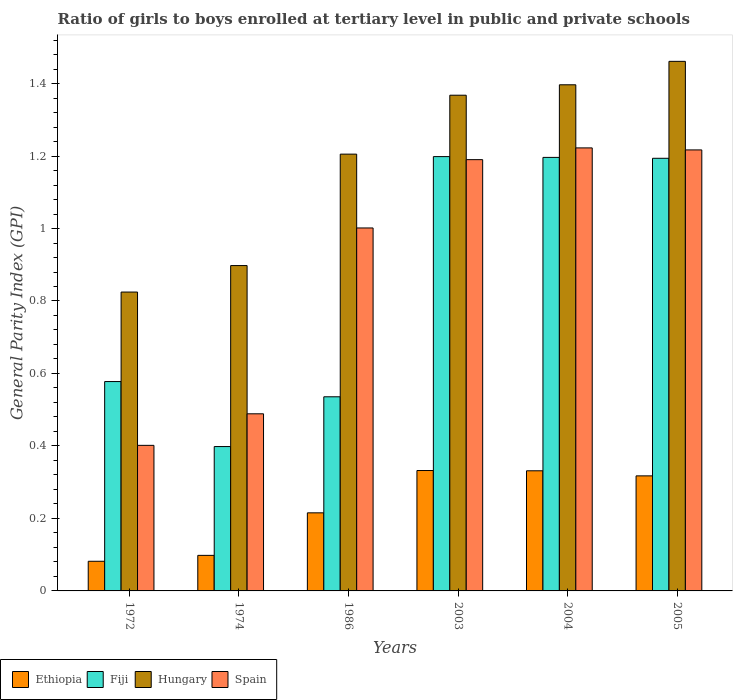How many groups of bars are there?
Offer a very short reply. 6. Are the number of bars per tick equal to the number of legend labels?
Make the answer very short. Yes. How many bars are there on the 1st tick from the right?
Keep it short and to the point. 4. What is the label of the 2nd group of bars from the left?
Keep it short and to the point. 1974. What is the general parity index in Spain in 2005?
Offer a very short reply. 1.22. Across all years, what is the maximum general parity index in Ethiopia?
Offer a terse response. 0.33. Across all years, what is the minimum general parity index in Spain?
Ensure brevity in your answer.  0.4. What is the total general parity index in Hungary in the graph?
Give a very brief answer. 7.15. What is the difference between the general parity index in Ethiopia in 1972 and that in 2003?
Provide a succinct answer. -0.25. What is the difference between the general parity index in Ethiopia in 1974 and the general parity index in Spain in 1972?
Keep it short and to the point. -0.3. What is the average general parity index in Fiji per year?
Your answer should be compact. 0.85. In the year 2003, what is the difference between the general parity index in Spain and general parity index in Fiji?
Your response must be concise. -0.01. In how many years, is the general parity index in Spain greater than 1.2800000000000002?
Provide a short and direct response. 0. What is the ratio of the general parity index in Ethiopia in 1974 to that in 2003?
Keep it short and to the point. 0.3. Is the difference between the general parity index in Spain in 1974 and 2004 greater than the difference between the general parity index in Fiji in 1974 and 2004?
Your response must be concise. Yes. What is the difference between the highest and the second highest general parity index in Spain?
Ensure brevity in your answer.  0.01. What is the difference between the highest and the lowest general parity index in Spain?
Your answer should be compact. 0.82. In how many years, is the general parity index in Spain greater than the average general parity index in Spain taken over all years?
Ensure brevity in your answer.  4. Is the sum of the general parity index in Fiji in 1974 and 1986 greater than the maximum general parity index in Spain across all years?
Provide a succinct answer. No. What does the 3rd bar from the left in 1986 represents?
Your answer should be very brief. Hungary. What does the 3rd bar from the right in 2003 represents?
Provide a succinct answer. Fiji. How many bars are there?
Offer a very short reply. 24. Are all the bars in the graph horizontal?
Make the answer very short. No. What is the difference between two consecutive major ticks on the Y-axis?
Your response must be concise. 0.2. How are the legend labels stacked?
Your answer should be very brief. Horizontal. What is the title of the graph?
Your answer should be compact. Ratio of girls to boys enrolled at tertiary level in public and private schools. What is the label or title of the X-axis?
Provide a succinct answer. Years. What is the label or title of the Y-axis?
Give a very brief answer. General Parity Index (GPI). What is the General Parity Index (GPI) of Ethiopia in 1972?
Offer a very short reply. 0.08. What is the General Parity Index (GPI) in Fiji in 1972?
Give a very brief answer. 0.58. What is the General Parity Index (GPI) in Hungary in 1972?
Give a very brief answer. 0.82. What is the General Parity Index (GPI) in Spain in 1972?
Offer a very short reply. 0.4. What is the General Parity Index (GPI) in Ethiopia in 1974?
Provide a succinct answer. 0.1. What is the General Parity Index (GPI) in Fiji in 1974?
Keep it short and to the point. 0.4. What is the General Parity Index (GPI) in Hungary in 1974?
Give a very brief answer. 0.9. What is the General Parity Index (GPI) of Spain in 1974?
Your answer should be very brief. 0.49. What is the General Parity Index (GPI) of Ethiopia in 1986?
Ensure brevity in your answer.  0.22. What is the General Parity Index (GPI) in Fiji in 1986?
Your answer should be compact. 0.54. What is the General Parity Index (GPI) of Hungary in 1986?
Provide a short and direct response. 1.21. What is the General Parity Index (GPI) in Spain in 1986?
Offer a terse response. 1. What is the General Parity Index (GPI) in Ethiopia in 2003?
Your answer should be very brief. 0.33. What is the General Parity Index (GPI) of Fiji in 2003?
Ensure brevity in your answer.  1.2. What is the General Parity Index (GPI) in Hungary in 2003?
Your answer should be very brief. 1.37. What is the General Parity Index (GPI) in Spain in 2003?
Ensure brevity in your answer.  1.19. What is the General Parity Index (GPI) in Ethiopia in 2004?
Make the answer very short. 0.33. What is the General Parity Index (GPI) of Fiji in 2004?
Provide a succinct answer. 1.2. What is the General Parity Index (GPI) in Hungary in 2004?
Make the answer very short. 1.4. What is the General Parity Index (GPI) in Spain in 2004?
Offer a terse response. 1.22. What is the General Parity Index (GPI) in Ethiopia in 2005?
Ensure brevity in your answer.  0.32. What is the General Parity Index (GPI) in Fiji in 2005?
Offer a very short reply. 1.19. What is the General Parity Index (GPI) of Hungary in 2005?
Keep it short and to the point. 1.46. What is the General Parity Index (GPI) in Spain in 2005?
Offer a terse response. 1.22. Across all years, what is the maximum General Parity Index (GPI) in Ethiopia?
Your answer should be compact. 0.33. Across all years, what is the maximum General Parity Index (GPI) of Fiji?
Provide a short and direct response. 1.2. Across all years, what is the maximum General Parity Index (GPI) of Hungary?
Make the answer very short. 1.46. Across all years, what is the maximum General Parity Index (GPI) in Spain?
Offer a very short reply. 1.22. Across all years, what is the minimum General Parity Index (GPI) in Ethiopia?
Give a very brief answer. 0.08. Across all years, what is the minimum General Parity Index (GPI) in Fiji?
Your response must be concise. 0.4. Across all years, what is the minimum General Parity Index (GPI) in Hungary?
Offer a very short reply. 0.82. Across all years, what is the minimum General Parity Index (GPI) of Spain?
Your response must be concise. 0.4. What is the total General Parity Index (GPI) in Ethiopia in the graph?
Provide a short and direct response. 1.38. What is the total General Parity Index (GPI) of Fiji in the graph?
Your answer should be very brief. 5.1. What is the total General Parity Index (GPI) in Hungary in the graph?
Provide a short and direct response. 7.15. What is the total General Parity Index (GPI) in Spain in the graph?
Your answer should be very brief. 5.52. What is the difference between the General Parity Index (GPI) of Ethiopia in 1972 and that in 1974?
Provide a short and direct response. -0.02. What is the difference between the General Parity Index (GPI) of Fiji in 1972 and that in 1974?
Provide a succinct answer. 0.18. What is the difference between the General Parity Index (GPI) of Hungary in 1972 and that in 1974?
Your answer should be compact. -0.07. What is the difference between the General Parity Index (GPI) in Spain in 1972 and that in 1974?
Provide a short and direct response. -0.09. What is the difference between the General Parity Index (GPI) in Ethiopia in 1972 and that in 1986?
Offer a terse response. -0.13. What is the difference between the General Parity Index (GPI) in Fiji in 1972 and that in 1986?
Offer a very short reply. 0.04. What is the difference between the General Parity Index (GPI) in Hungary in 1972 and that in 1986?
Offer a very short reply. -0.38. What is the difference between the General Parity Index (GPI) of Spain in 1972 and that in 1986?
Offer a terse response. -0.6. What is the difference between the General Parity Index (GPI) in Ethiopia in 1972 and that in 2003?
Make the answer very short. -0.25. What is the difference between the General Parity Index (GPI) in Fiji in 1972 and that in 2003?
Give a very brief answer. -0.62. What is the difference between the General Parity Index (GPI) of Hungary in 1972 and that in 2003?
Provide a succinct answer. -0.54. What is the difference between the General Parity Index (GPI) of Spain in 1972 and that in 2003?
Provide a succinct answer. -0.79. What is the difference between the General Parity Index (GPI) of Ethiopia in 1972 and that in 2004?
Offer a terse response. -0.25. What is the difference between the General Parity Index (GPI) in Fiji in 1972 and that in 2004?
Ensure brevity in your answer.  -0.62. What is the difference between the General Parity Index (GPI) of Hungary in 1972 and that in 2004?
Keep it short and to the point. -0.57. What is the difference between the General Parity Index (GPI) of Spain in 1972 and that in 2004?
Your answer should be compact. -0.82. What is the difference between the General Parity Index (GPI) of Ethiopia in 1972 and that in 2005?
Your answer should be very brief. -0.24. What is the difference between the General Parity Index (GPI) of Fiji in 1972 and that in 2005?
Your response must be concise. -0.62. What is the difference between the General Parity Index (GPI) in Hungary in 1972 and that in 2005?
Your answer should be very brief. -0.64. What is the difference between the General Parity Index (GPI) in Spain in 1972 and that in 2005?
Provide a succinct answer. -0.82. What is the difference between the General Parity Index (GPI) in Ethiopia in 1974 and that in 1986?
Give a very brief answer. -0.12. What is the difference between the General Parity Index (GPI) of Fiji in 1974 and that in 1986?
Your answer should be compact. -0.14. What is the difference between the General Parity Index (GPI) in Hungary in 1974 and that in 1986?
Your answer should be compact. -0.31. What is the difference between the General Parity Index (GPI) in Spain in 1974 and that in 1986?
Your answer should be compact. -0.51. What is the difference between the General Parity Index (GPI) of Ethiopia in 1974 and that in 2003?
Your response must be concise. -0.23. What is the difference between the General Parity Index (GPI) in Fiji in 1974 and that in 2003?
Keep it short and to the point. -0.8. What is the difference between the General Parity Index (GPI) in Hungary in 1974 and that in 2003?
Your answer should be very brief. -0.47. What is the difference between the General Parity Index (GPI) of Spain in 1974 and that in 2003?
Your response must be concise. -0.7. What is the difference between the General Parity Index (GPI) in Ethiopia in 1974 and that in 2004?
Offer a very short reply. -0.23. What is the difference between the General Parity Index (GPI) in Fiji in 1974 and that in 2004?
Offer a very short reply. -0.8. What is the difference between the General Parity Index (GPI) in Hungary in 1974 and that in 2004?
Your answer should be compact. -0.5. What is the difference between the General Parity Index (GPI) in Spain in 1974 and that in 2004?
Keep it short and to the point. -0.73. What is the difference between the General Parity Index (GPI) of Ethiopia in 1974 and that in 2005?
Keep it short and to the point. -0.22. What is the difference between the General Parity Index (GPI) in Fiji in 1974 and that in 2005?
Offer a very short reply. -0.8. What is the difference between the General Parity Index (GPI) in Hungary in 1974 and that in 2005?
Keep it short and to the point. -0.56. What is the difference between the General Parity Index (GPI) of Spain in 1974 and that in 2005?
Make the answer very short. -0.73. What is the difference between the General Parity Index (GPI) in Ethiopia in 1986 and that in 2003?
Your answer should be very brief. -0.12. What is the difference between the General Parity Index (GPI) of Fiji in 1986 and that in 2003?
Keep it short and to the point. -0.66. What is the difference between the General Parity Index (GPI) in Hungary in 1986 and that in 2003?
Offer a very short reply. -0.16. What is the difference between the General Parity Index (GPI) of Spain in 1986 and that in 2003?
Ensure brevity in your answer.  -0.19. What is the difference between the General Parity Index (GPI) of Ethiopia in 1986 and that in 2004?
Your answer should be very brief. -0.12. What is the difference between the General Parity Index (GPI) of Fiji in 1986 and that in 2004?
Make the answer very short. -0.66. What is the difference between the General Parity Index (GPI) of Hungary in 1986 and that in 2004?
Your answer should be compact. -0.19. What is the difference between the General Parity Index (GPI) of Spain in 1986 and that in 2004?
Provide a succinct answer. -0.22. What is the difference between the General Parity Index (GPI) of Ethiopia in 1986 and that in 2005?
Ensure brevity in your answer.  -0.1. What is the difference between the General Parity Index (GPI) of Fiji in 1986 and that in 2005?
Your answer should be compact. -0.66. What is the difference between the General Parity Index (GPI) in Hungary in 1986 and that in 2005?
Provide a short and direct response. -0.26. What is the difference between the General Parity Index (GPI) in Spain in 1986 and that in 2005?
Provide a short and direct response. -0.22. What is the difference between the General Parity Index (GPI) in Ethiopia in 2003 and that in 2004?
Offer a very short reply. 0. What is the difference between the General Parity Index (GPI) in Fiji in 2003 and that in 2004?
Give a very brief answer. 0. What is the difference between the General Parity Index (GPI) in Hungary in 2003 and that in 2004?
Make the answer very short. -0.03. What is the difference between the General Parity Index (GPI) of Spain in 2003 and that in 2004?
Provide a succinct answer. -0.03. What is the difference between the General Parity Index (GPI) in Ethiopia in 2003 and that in 2005?
Provide a succinct answer. 0.01. What is the difference between the General Parity Index (GPI) in Fiji in 2003 and that in 2005?
Give a very brief answer. 0. What is the difference between the General Parity Index (GPI) in Hungary in 2003 and that in 2005?
Ensure brevity in your answer.  -0.09. What is the difference between the General Parity Index (GPI) in Spain in 2003 and that in 2005?
Provide a succinct answer. -0.03. What is the difference between the General Parity Index (GPI) of Ethiopia in 2004 and that in 2005?
Ensure brevity in your answer.  0.01. What is the difference between the General Parity Index (GPI) of Fiji in 2004 and that in 2005?
Your answer should be compact. 0. What is the difference between the General Parity Index (GPI) of Hungary in 2004 and that in 2005?
Provide a succinct answer. -0.06. What is the difference between the General Parity Index (GPI) of Spain in 2004 and that in 2005?
Provide a short and direct response. 0.01. What is the difference between the General Parity Index (GPI) in Ethiopia in 1972 and the General Parity Index (GPI) in Fiji in 1974?
Offer a very short reply. -0.32. What is the difference between the General Parity Index (GPI) of Ethiopia in 1972 and the General Parity Index (GPI) of Hungary in 1974?
Your response must be concise. -0.82. What is the difference between the General Parity Index (GPI) in Ethiopia in 1972 and the General Parity Index (GPI) in Spain in 1974?
Keep it short and to the point. -0.41. What is the difference between the General Parity Index (GPI) of Fiji in 1972 and the General Parity Index (GPI) of Hungary in 1974?
Your response must be concise. -0.32. What is the difference between the General Parity Index (GPI) in Fiji in 1972 and the General Parity Index (GPI) in Spain in 1974?
Give a very brief answer. 0.09. What is the difference between the General Parity Index (GPI) in Hungary in 1972 and the General Parity Index (GPI) in Spain in 1974?
Offer a very short reply. 0.34. What is the difference between the General Parity Index (GPI) of Ethiopia in 1972 and the General Parity Index (GPI) of Fiji in 1986?
Offer a terse response. -0.45. What is the difference between the General Parity Index (GPI) in Ethiopia in 1972 and the General Parity Index (GPI) in Hungary in 1986?
Offer a very short reply. -1.12. What is the difference between the General Parity Index (GPI) in Ethiopia in 1972 and the General Parity Index (GPI) in Spain in 1986?
Offer a terse response. -0.92. What is the difference between the General Parity Index (GPI) of Fiji in 1972 and the General Parity Index (GPI) of Hungary in 1986?
Your answer should be very brief. -0.63. What is the difference between the General Parity Index (GPI) of Fiji in 1972 and the General Parity Index (GPI) of Spain in 1986?
Give a very brief answer. -0.42. What is the difference between the General Parity Index (GPI) of Hungary in 1972 and the General Parity Index (GPI) of Spain in 1986?
Provide a short and direct response. -0.18. What is the difference between the General Parity Index (GPI) in Ethiopia in 1972 and the General Parity Index (GPI) in Fiji in 2003?
Provide a short and direct response. -1.12. What is the difference between the General Parity Index (GPI) in Ethiopia in 1972 and the General Parity Index (GPI) in Hungary in 2003?
Provide a succinct answer. -1.29. What is the difference between the General Parity Index (GPI) in Ethiopia in 1972 and the General Parity Index (GPI) in Spain in 2003?
Your response must be concise. -1.11. What is the difference between the General Parity Index (GPI) of Fiji in 1972 and the General Parity Index (GPI) of Hungary in 2003?
Provide a succinct answer. -0.79. What is the difference between the General Parity Index (GPI) in Fiji in 1972 and the General Parity Index (GPI) in Spain in 2003?
Your response must be concise. -0.61. What is the difference between the General Parity Index (GPI) of Hungary in 1972 and the General Parity Index (GPI) of Spain in 2003?
Provide a succinct answer. -0.37. What is the difference between the General Parity Index (GPI) of Ethiopia in 1972 and the General Parity Index (GPI) of Fiji in 2004?
Provide a short and direct response. -1.11. What is the difference between the General Parity Index (GPI) in Ethiopia in 1972 and the General Parity Index (GPI) in Hungary in 2004?
Give a very brief answer. -1.31. What is the difference between the General Parity Index (GPI) of Ethiopia in 1972 and the General Parity Index (GPI) of Spain in 2004?
Your response must be concise. -1.14. What is the difference between the General Parity Index (GPI) of Fiji in 1972 and the General Parity Index (GPI) of Hungary in 2004?
Offer a very short reply. -0.82. What is the difference between the General Parity Index (GPI) of Fiji in 1972 and the General Parity Index (GPI) of Spain in 2004?
Offer a very short reply. -0.64. What is the difference between the General Parity Index (GPI) in Hungary in 1972 and the General Parity Index (GPI) in Spain in 2004?
Provide a short and direct response. -0.4. What is the difference between the General Parity Index (GPI) of Ethiopia in 1972 and the General Parity Index (GPI) of Fiji in 2005?
Ensure brevity in your answer.  -1.11. What is the difference between the General Parity Index (GPI) in Ethiopia in 1972 and the General Parity Index (GPI) in Hungary in 2005?
Make the answer very short. -1.38. What is the difference between the General Parity Index (GPI) in Ethiopia in 1972 and the General Parity Index (GPI) in Spain in 2005?
Your answer should be compact. -1.14. What is the difference between the General Parity Index (GPI) in Fiji in 1972 and the General Parity Index (GPI) in Hungary in 2005?
Ensure brevity in your answer.  -0.88. What is the difference between the General Parity Index (GPI) of Fiji in 1972 and the General Parity Index (GPI) of Spain in 2005?
Provide a short and direct response. -0.64. What is the difference between the General Parity Index (GPI) of Hungary in 1972 and the General Parity Index (GPI) of Spain in 2005?
Keep it short and to the point. -0.39. What is the difference between the General Parity Index (GPI) of Ethiopia in 1974 and the General Parity Index (GPI) of Fiji in 1986?
Provide a short and direct response. -0.44. What is the difference between the General Parity Index (GPI) of Ethiopia in 1974 and the General Parity Index (GPI) of Hungary in 1986?
Your answer should be very brief. -1.11. What is the difference between the General Parity Index (GPI) of Ethiopia in 1974 and the General Parity Index (GPI) of Spain in 1986?
Ensure brevity in your answer.  -0.9. What is the difference between the General Parity Index (GPI) of Fiji in 1974 and the General Parity Index (GPI) of Hungary in 1986?
Provide a succinct answer. -0.81. What is the difference between the General Parity Index (GPI) in Fiji in 1974 and the General Parity Index (GPI) in Spain in 1986?
Give a very brief answer. -0.6. What is the difference between the General Parity Index (GPI) of Hungary in 1974 and the General Parity Index (GPI) of Spain in 1986?
Give a very brief answer. -0.1. What is the difference between the General Parity Index (GPI) of Ethiopia in 1974 and the General Parity Index (GPI) of Fiji in 2003?
Your answer should be compact. -1.1. What is the difference between the General Parity Index (GPI) in Ethiopia in 1974 and the General Parity Index (GPI) in Hungary in 2003?
Offer a terse response. -1.27. What is the difference between the General Parity Index (GPI) of Ethiopia in 1974 and the General Parity Index (GPI) of Spain in 2003?
Give a very brief answer. -1.09. What is the difference between the General Parity Index (GPI) in Fiji in 1974 and the General Parity Index (GPI) in Hungary in 2003?
Make the answer very short. -0.97. What is the difference between the General Parity Index (GPI) of Fiji in 1974 and the General Parity Index (GPI) of Spain in 2003?
Offer a terse response. -0.79. What is the difference between the General Parity Index (GPI) in Hungary in 1974 and the General Parity Index (GPI) in Spain in 2003?
Your answer should be very brief. -0.29. What is the difference between the General Parity Index (GPI) in Ethiopia in 1974 and the General Parity Index (GPI) in Fiji in 2004?
Make the answer very short. -1.1. What is the difference between the General Parity Index (GPI) of Ethiopia in 1974 and the General Parity Index (GPI) of Hungary in 2004?
Provide a short and direct response. -1.3. What is the difference between the General Parity Index (GPI) of Ethiopia in 1974 and the General Parity Index (GPI) of Spain in 2004?
Your answer should be very brief. -1.12. What is the difference between the General Parity Index (GPI) in Fiji in 1974 and the General Parity Index (GPI) in Hungary in 2004?
Your answer should be compact. -1. What is the difference between the General Parity Index (GPI) in Fiji in 1974 and the General Parity Index (GPI) in Spain in 2004?
Your response must be concise. -0.82. What is the difference between the General Parity Index (GPI) in Hungary in 1974 and the General Parity Index (GPI) in Spain in 2004?
Your answer should be compact. -0.32. What is the difference between the General Parity Index (GPI) of Ethiopia in 1974 and the General Parity Index (GPI) of Fiji in 2005?
Offer a terse response. -1.1. What is the difference between the General Parity Index (GPI) in Ethiopia in 1974 and the General Parity Index (GPI) in Hungary in 2005?
Your answer should be compact. -1.36. What is the difference between the General Parity Index (GPI) of Ethiopia in 1974 and the General Parity Index (GPI) of Spain in 2005?
Offer a terse response. -1.12. What is the difference between the General Parity Index (GPI) of Fiji in 1974 and the General Parity Index (GPI) of Hungary in 2005?
Provide a short and direct response. -1.06. What is the difference between the General Parity Index (GPI) in Fiji in 1974 and the General Parity Index (GPI) in Spain in 2005?
Give a very brief answer. -0.82. What is the difference between the General Parity Index (GPI) in Hungary in 1974 and the General Parity Index (GPI) in Spain in 2005?
Keep it short and to the point. -0.32. What is the difference between the General Parity Index (GPI) of Ethiopia in 1986 and the General Parity Index (GPI) of Fiji in 2003?
Your response must be concise. -0.98. What is the difference between the General Parity Index (GPI) in Ethiopia in 1986 and the General Parity Index (GPI) in Hungary in 2003?
Make the answer very short. -1.15. What is the difference between the General Parity Index (GPI) in Ethiopia in 1986 and the General Parity Index (GPI) in Spain in 2003?
Provide a short and direct response. -0.97. What is the difference between the General Parity Index (GPI) in Fiji in 1986 and the General Parity Index (GPI) in Hungary in 2003?
Keep it short and to the point. -0.83. What is the difference between the General Parity Index (GPI) of Fiji in 1986 and the General Parity Index (GPI) of Spain in 2003?
Make the answer very short. -0.65. What is the difference between the General Parity Index (GPI) in Hungary in 1986 and the General Parity Index (GPI) in Spain in 2003?
Your response must be concise. 0.02. What is the difference between the General Parity Index (GPI) of Ethiopia in 1986 and the General Parity Index (GPI) of Fiji in 2004?
Offer a very short reply. -0.98. What is the difference between the General Parity Index (GPI) of Ethiopia in 1986 and the General Parity Index (GPI) of Hungary in 2004?
Provide a succinct answer. -1.18. What is the difference between the General Parity Index (GPI) of Ethiopia in 1986 and the General Parity Index (GPI) of Spain in 2004?
Ensure brevity in your answer.  -1.01. What is the difference between the General Parity Index (GPI) in Fiji in 1986 and the General Parity Index (GPI) in Hungary in 2004?
Provide a short and direct response. -0.86. What is the difference between the General Parity Index (GPI) of Fiji in 1986 and the General Parity Index (GPI) of Spain in 2004?
Ensure brevity in your answer.  -0.69. What is the difference between the General Parity Index (GPI) of Hungary in 1986 and the General Parity Index (GPI) of Spain in 2004?
Your answer should be very brief. -0.02. What is the difference between the General Parity Index (GPI) in Ethiopia in 1986 and the General Parity Index (GPI) in Fiji in 2005?
Offer a very short reply. -0.98. What is the difference between the General Parity Index (GPI) of Ethiopia in 1986 and the General Parity Index (GPI) of Hungary in 2005?
Offer a terse response. -1.25. What is the difference between the General Parity Index (GPI) in Ethiopia in 1986 and the General Parity Index (GPI) in Spain in 2005?
Your answer should be compact. -1. What is the difference between the General Parity Index (GPI) in Fiji in 1986 and the General Parity Index (GPI) in Hungary in 2005?
Ensure brevity in your answer.  -0.93. What is the difference between the General Parity Index (GPI) in Fiji in 1986 and the General Parity Index (GPI) in Spain in 2005?
Your response must be concise. -0.68. What is the difference between the General Parity Index (GPI) in Hungary in 1986 and the General Parity Index (GPI) in Spain in 2005?
Offer a terse response. -0.01. What is the difference between the General Parity Index (GPI) of Ethiopia in 2003 and the General Parity Index (GPI) of Fiji in 2004?
Keep it short and to the point. -0.86. What is the difference between the General Parity Index (GPI) in Ethiopia in 2003 and the General Parity Index (GPI) in Hungary in 2004?
Make the answer very short. -1.06. What is the difference between the General Parity Index (GPI) in Ethiopia in 2003 and the General Parity Index (GPI) in Spain in 2004?
Your answer should be compact. -0.89. What is the difference between the General Parity Index (GPI) of Fiji in 2003 and the General Parity Index (GPI) of Hungary in 2004?
Offer a terse response. -0.2. What is the difference between the General Parity Index (GPI) of Fiji in 2003 and the General Parity Index (GPI) of Spain in 2004?
Make the answer very short. -0.02. What is the difference between the General Parity Index (GPI) of Hungary in 2003 and the General Parity Index (GPI) of Spain in 2004?
Make the answer very short. 0.15. What is the difference between the General Parity Index (GPI) in Ethiopia in 2003 and the General Parity Index (GPI) in Fiji in 2005?
Ensure brevity in your answer.  -0.86. What is the difference between the General Parity Index (GPI) of Ethiopia in 2003 and the General Parity Index (GPI) of Hungary in 2005?
Keep it short and to the point. -1.13. What is the difference between the General Parity Index (GPI) of Ethiopia in 2003 and the General Parity Index (GPI) of Spain in 2005?
Give a very brief answer. -0.88. What is the difference between the General Parity Index (GPI) in Fiji in 2003 and the General Parity Index (GPI) in Hungary in 2005?
Make the answer very short. -0.26. What is the difference between the General Parity Index (GPI) in Fiji in 2003 and the General Parity Index (GPI) in Spain in 2005?
Your answer should be very brief. -0.02. What is the difference between the General Parity Index (GPI) of Hungary in 2003 and the General Parity Index (GPI) of Spain in 2005?
Keep it short and to the point. 0.15. What is the difference between the General Parity Index (GPI) of Ethiopia in 2004 and the General Parity Index (GPI) of Fiji in 2005?
Your answer should be compact. -0.86. What is the difference between the General Parity Index (GPI) in Ethiopia in 2004 and the General Parity Index (GPI) in Hungary in 2005?
Offer a terse response. -1.13. What is the difference between the General Parity Index (GPI) in Ethiopia in 2004 and the General Parity Index (GPI) in Spain in 2005?
Your answer should be compact. -0.89. What is the difference between the General Parity Index (GPI) of Fiji in 2004 and the General Parity Index (GPI) of Hungary in 2005?
Your answer should be compact. -0.27. What is the difference between the General Parity Index (GPI) in Fiji in 2004 and the General Parity Index (GPI) in Spain in 2005?
Keep it short and to the point. -0.02. What is the difference between the General Parity Index (GPI) in Hungary in 2004 and the General Parity Index (GPI) in Spain in 2005?
Keep it short and to the point. 0.18. What is the average General Parity Index (GPI) of Ethiopia per year?
Provide a short and direct response. 0.23. What is the average General Parity Index (GPI) in Hungary per year?
Keep it short and to the point. 1.19. What is the average General Parity Index (GPI) of Spain per year?
Provide a succinct answer. 0.92. In the year 1972, what is the difference between the General Parity Index (GPI) of Ethiopia and General Parity Index (GPI) of Fiji?
Your response must be concise. -0.5. In the year 1972, what is the difference between the General Parity Index (GPI) of Ethiopia and General Parity Index (GPI) of Hungary?
Offer a terse response. -0.74. In the year 1972, what is the difference between the General Parity Index (GPI) in Ethiopia and General Parity Index (GPI) in Spain?
Provide a short and direct response. -0.32. In the year 1972, what is the difference between the General Parity Index (GPI) of Fiji and General Parity Index (GPI) of Hungary?
Provide a succinct answer. -0.25. In the year 1972, what is the difference between the General Parity Index (GPI) of Fiji and General Parity Index (GPI) of Spain?
Offer a very short reply. 0.18. In the year 1972, what is the difference between the General Parity Index (GPI) of Hungary and General Parity Index (GPI) of Spain?
Your answer should be compact. 0.42. In the year 1974, what is the difference between the General Parity Index (GPI) of Ethiopia and General Parity Index (GPI) of Fiji?
Ensure brevity in your answer.  -0.3. In the year 1974, what is the difference between the General Parity Index (GPI) of Ethiopia and General Parity Index (GPI) of Hungary?
Ensure brevity in your answer.  -0.8. In the year 1974, what is the difference between the General Parity Index (GPI) of Ethiopia and General Parity Index (GPI) of Spain?
Provide a succinct answer. -0.39. In the year 1974, what is the difference between the General Parity Index (GPI) of Fiji and General Parity Index (GPI) of Hungary?
Your answer should be very brief. -0.5. In the year 1974, what is the difference between the General Parity Index (GPI) of Fiji and General Parity Index (GPI) of Spain?
Provide a short and direct response. -0.09. In the year 1974, what is the difference between the General Parity Index (GPI) in Hungary and General Parity Index (GPI) in Spain?
Your response must be concise. 0.41. In the year 1986, what is the difference between the General Parity Index (GPI) in Ethiopia and General Parity Index (GPI) in Fiji?
Your answer should be compact. -0.32. In the year 1986, what is the difference between the General Parity Index (GPI) of Ethiopia and General Parity Index (GPI) of Hungary?
Offer a terse response. -0.99. In the year 1986, what is the difference between the General Parity Index (GPI) of Ethiopia and General Parity Index (GPI) of Spain?
Provide a succinct answer. -0.79. In the year 1986, what is the difference between the General Parity Index (GPI) in Fiji and General Parity Index (GPI) in Hungary?
Your response must be concise. -0.67. In the year 1986, what is the difference between the General Parity Index (GPI) in Fiji and General Parity Index (GPI) in Spain?
Make the answer very short. -0.47. In the year 1986, what is the difference between the General Parity Index (GPI) of Hungary and General Parity Index (GPI) of Spain?
Your answer should be compact. 0.2. In the year 2003, what is the difference between the General Parity Index (GPI) in Ethiopia and General Parity Index (GPI) in Fiji?
Offer a terse response. -0.87. In the year 2003, what is the difference between the General Parity Index (GPI) of Ethiopia and General Parity Index (GPI) of Hungary?
Offer a terse response. -1.04. In the year 2003, what is the difference between the General Parity Index (GPI) in Ethiopia and General Parity Index (GPI) in Spain?
Provide a succinct answer. -0.86. In the year 2003, what is the difference between the General Parity Index (GPI) of Fiji and General Parity Index (GPI) of Hungary?
Offer a terse response. -0.17. In the year 2003, what is the difference between the General Parity Index (GPI) in Fiji and General Parity Index (GPI) in Spain?
Provide a short and direct response. 0.01. In the year 2003, what is the difference between the General Parity Index (GPI) in Hungary and General Parity Index (GPI) in Spain?
Ensure brevity in your answer.  0.18. In the year 2004, what is the difference between the General Parity Index (GPI) in Ethiopia and General Parity Index (GPI) in Fiji?
Your response must be concise. -0.86. In the year 2004, what is the difference between the General Parity Index (GPI) of Ethiopia and General Parity Index (GPI) of Hungary?
Your answer should be compact. -1.07. In the year 2004, what is the difference between the General Parity Index (GPI) in Ethiopia and General Parity Index (GPI) in Spain?
Offer a very short reply. -0.89. In the year 2004, what is the difference between the General Parity Index (GPI) in Fiji and General Parity Index (GPI) in Hungary?
Offer a terse response. -0.2. In the year 2004, what is the difference between the General Parity Index (GPI) of Fiji and General Parity Index (GPI) of Spain?
Make the answer very short. -0.03. In the year 2004, what is the difference between the General Parity Index (GPI) of Hungary and General Parity Index (GPI) of Spain?
Provide a succinct answer. 0.17. In the year 2005, what is the difference between the General Parity Index (GPI) in Ethiopia and General Parity Index (GPI) in Fiji?
Your response must be concise. -0.88. In the year 2005, what is the difference between the General Parity Index (GPI) in Ethiopia and General Parity Index (GPI) in Hungary?
Provide a succinct answer. -1.14. In the year 2005, what is the difference between the General Parity Index (GPI) in Ethiopia and General Parity Index (GPI) in Spain?
Offer a very short reply. -0.9. In the year 2005, what is the difference between the General Parity Index (GPI) of Fiji and General Parity Index (GPI) of Hungary?
Your response must be concise. -0.27. In the year 2005, what is the difference between the General Parity Index (GPI) of Fiji and General Parity Index (GPI) of Spain?
Ensure brevity in your answer.  -0.02. In the year 2005, what is the difference between the General Parity Index (GPI) in Hungary and General Parity Index (GPI) in Spain?
Make the answer very short. 0.24. What is the ratio of the General Parity Index (GPI) in Ethiopia in 1972 to that in 1974?
Your answer should be compact. 0.83. What is the ratio of the General Parity Index (GPI) of Fiji in 1972 to that in 1974?
Give a very brief answer. 1.45. What is the ratio of the General Parity Index (GPI) of Hungary in 1972 to that in 1974?
Make the answer very short. 0.92. What is the ratio of the General Parity Index (GPI) of Spain in 1972 to that in 1974?
Offer a terse response. 0.82. What is the ratio of the General Parity Index (GPI) in Ethiopia in 1972 to that in 1986?
Your answer should be compact. 0.38. What is the ratio of the General Parity Index (GPI) of Fiji in 1972 to that in 1986?
Your answer should be very brief. 1.08. What is the ratio of the General Parity Index (GPI) of Hungary in 1972 to that in 1986?
Your response must be concise. 0.68. What is the ratio of the General Parity Index (GPI) in Spain in 1972 to that in 1986?
Provide a short and direct response. 0.4. What is the ratio of the General Parity Index (GPI) in Ethiopia in 1972 to that in 2003?
Your answer should be compact. 0.25. What is the ratio of the General Parity Index (GPI) of Fiji in 1972 to that in 2003?
Keep it short and to the point. 0.48. What is the ratio of the General Parity Index (GPI) of Hungary in 1972 to that in 2003?
Offer a terse response. 0.6. What is the ratio of the General Parity Index (GPI) in Spain in 1972 to that in 2003?
Your answer should be compact. 0.34. What is the ratio of the General Parity Index (GPI) in Ethiopia in 1972 to that in 2004?
Ensure brevity in your answer.  0.25. What is the ratio of the General Parity Index (GPI) in Fiji in 1972 to that in 2004?
Provide a succinct answer. 0.48. What is the ratio of the General Parity Index (GPI) in Hungary in 1972 to that in 2004?
Offer a very short reply. 0.59. What is the ratio of the General Parity Index (GPI) of Spain in 1972 to that in 2004?
Ensure brevity in your answer.  0.33. What is the ratio of the General Parity Index (GPI) in Ethiopia in 1972 to that in 2005?
Provide a succinct answer. 0.26. What is the ratio of the General Parity Index (GPI) of Fiji in 1972 to that in 2005?
Ensure brevity in your answer.  0.48. What is the ratio of the General Parity Index (GPI) of Hungary in 1972 to that in 2005?
Ensure brevity in your answer.  0.56. What is the ratio of the General Parity Index (GPI) in Spain in 1972 to that in 2005?
Offer a terse response. 0.33. What is the ratio of the General Parity Index (GPI) of Ethiopia in 1974 to that in 1986?
Offer a very short reply. 0.46. What is the ratio of the General Parity Index (GPI) of Fiji in 1974 to that in 1986?
Provide a short and direct response. 0.74. What is the ratio of the General Parity Index (GPI) in Hungary in 1974 to that in 1986?
Your answer should be very brief. 0.74. What is the ratio of the General Parity Index (GPI) in Spain in 1974 to that in 1986?
Make the answer very short. 0.49. What is the ratio of the General Parity Index (GPI) of Ethiopia in 1974 to that in 2003?
Your answer should be compact. 0.3. What is the ratio of the General Parity Index (GPI) in Fiji in 1974 to that in 2003?
Keep it short and to the point. 0.33. What is the ratio of the General Parity Index (GPI) in Hungary in 1974 to that in 2003?
Provide a short and direct response. 0.66. What is the ratio of the General Parity Index (GPI) of Spain in 1974 to that in 2003?
Make the answer very short. 0.41. What is the ratio of the General Parity Index (GPI) of Ethiopia in 1974 to that in 2004?
Your response must be concise. 0.3. What is the ratio of the General Parity Index (GPI) in Fiji in 1974 to that in 2004?
Give a very brief answer. 0.33. What is the ratio of the General Parity Index (GPI) in Hungary in 1974 to that in 2004?
Keep it short and to the point. 0.64. What is the ratio of the General Parity Index (GPI) in Spain in 1974 to that in 2004?
Offer a very short reply. 0.4. What is the ratio of the General Parity Index (GPI) of Ethiopia in 1974 to that in 2005?
Offer a terse response. 0.31. What is the ratio of the General Parity Index (GPI) in Fiji in 1974 to that in 2005?
Make the answer very short. 0.33. What is the ratio of the General Parity Index (GPI) in Hungary in 1974 to that in 2005?
Your answer should be very brief. 0.61. What is the ratio of the General Parity Index (GPI) of Spain in 1974 to that in 2005?
Offer a very short reply. 0.4. What is the ratio of the General Parity Index (GPI) of Ethiopia in 1986 to that in 2003?
Make the answer very short. 0.65. What is the ratio of the General Parity Index (GPI) in Fiji in 1986 to that in 2003?
Your answer should be very brief. 0.45. What is the ratio of the General Parity Index (GPI) in Hungary in 1986 to that in 2003?
Make the answer very short. 0.88. What is the ratio of the General Parity Index (GPI) of Spain in 1986 to that in 2003?
Your response must be concise. 0.84. What is the ratio of the General Parity Index (GPI) in Ethiopia in 1986 to that in 2004?
Give a very brief answer. 0.65. What is the ratio of the General Parity Index (GPI) of Fiji in 1986 to that in 2004?
Offer a terse response. 0.45. What is the ratio of the General Parity Index (GPI) of Hungary in 1986 to that in 2004?
Your answer should be compact. 0.86. What is the ratio of the General Parity Index (GPI) of Spain in 1986 to that in 2004?
Provide a short and direct response. 0.82. What is the ratio of the General Parity Index (GPI) of Ethiopia in 1986 to that in 2005?
Make the answer very short. 0.68. What is the ratio of the General Parity Index (GPI) of Fiji in 1986 to that in 2005?
Make the answer very short. 0.45. What is the ratio of the General Parity Index (GPI) of Hungary in 1986 to that in 2005?
Your answer should be compact. 0.82. What is the ratio of the General Parity Index (GPI) of Spain in 1986 to that in 2005?
Your answer should be compact. 0.82. What is the ratio of the General Parity Index (GPI) of Ethiopia in 2003 to that in 2004?
Your answer should be very brief. 1. What is the ratio of the General Parity Index (GPI) in Fiji in 2003 to that in 2004?
Offer a terse response. 1. What is the ratio of the General Parity Index (GPI) of Hungary in 2003 to that in 2004?
Your response must be concise. 0.98. What is the ratio of the General Parity Index (GPI) in Spain in 2003 to that in 2004?
Give a very brief answer. 0.97. What is the ratio of the General Parity Index (GPI) in Ethiopia in 2003 to that in 2005?
Provide a succinct answer. 1.05. What is the ratio of the General Parity Index (GPI) of Hungary in 2003 to that in 2005?
Your answer should be compact. 0.94. What is the ratio of the General Parity Index (GPI) in Spain in 2003 to that in 2005?
Provide a short and direct response. 0.98. What is the ratio of the General Parity Index (GPI) in Ethiopia in 2004 to that in 2005?
Your response must be concise. 1.04. What is the ratio of the General Parity Index (GPI) of Fiji in 2004 to that in 2005?
Offer a very short reply. 1. What is the ratio of the General Parity Index (GPI) in Hungary in 2004 to that in 2005?
Your answer should be very brief. 0.96. What is the difference between the highest and the second highest General Parity Index (GPI) of Ethiopia?
Ensure brevity in your answer.  0. What is the difference between the highest and the second highest General Parity Index (GPI) of Fiji?
Keep it short and to the point. 0. What is the difference between the highest and the second highest General Parity Index (GPI) in Hungary?
Your answer should be compact. 0.06. What is the difference between the highest and the second highest General Parity Index (GPI) in Spain?
Offer a terse response. 0.01. What is the difference between the highest and the lowest General Parity Index (GPI) of Ethiopia?
Offer a terse response. 0.25. What is the difference between the highest and the lowest General Parity Index (GPI) in Fiji?
Provide a short and direct response. 0.8. What is the difference between the highest and the lowest General Parity Index (GPI) of Hungary?
Make the answer very short. 0.64. What is the difference between the highest and the lowest General Parity Index (GPI) in Spain?
Give a very brief answer. 0.82. 